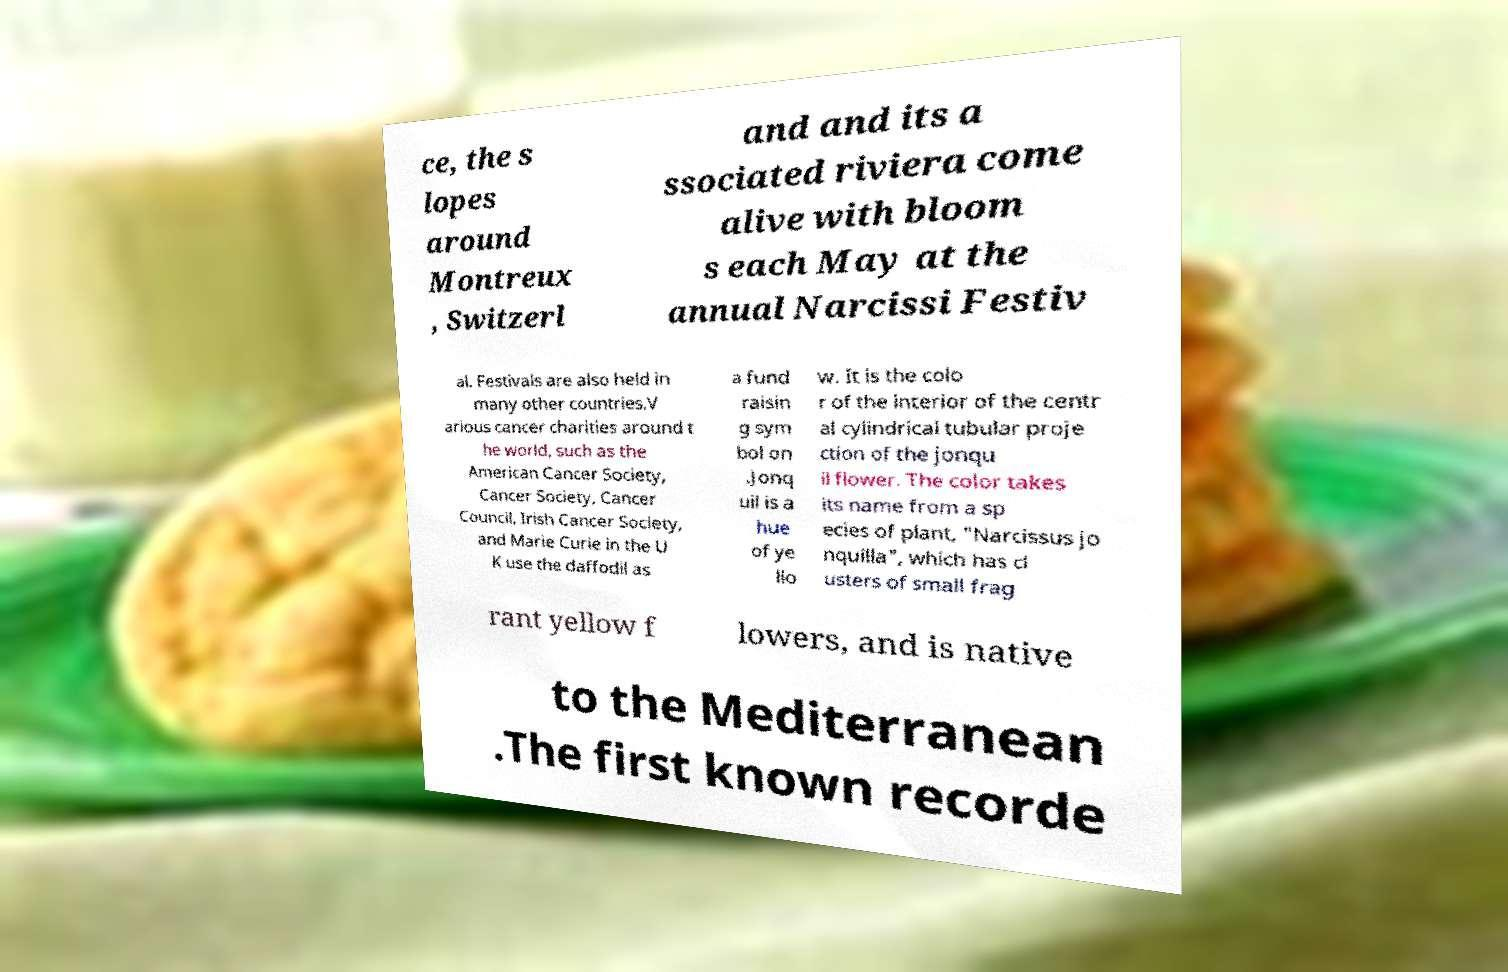Can you read and provide the text displayed in the image?This photo seems to have some interesting text. Can you extract and type it out for me? ce, the s lopes around Montreux , Switzerl and and its a ssociated riviera come alive with bloom s each May at the annual Narcissi Festiv al. Festivals are also held in many other countries.V arious cancer charities around t he world, such as the American Cancer Society, Cancer Society, Cancer Council, Irish Cancer Society, and Marie Curie in the U K use the daffodil as a fund raisin g sym bol on .Jonq uil is a hue of ye llo w. It is the colo r of the interior of the centr al cylindrical tubular proje ction of the jonqu il flower. The color takes its name from a sp ecies of plant, "Narcissus jo nquilla", which has cl usters of small frag rant yellow f lowers, and is native to the Mediterranean .The first known recorde 